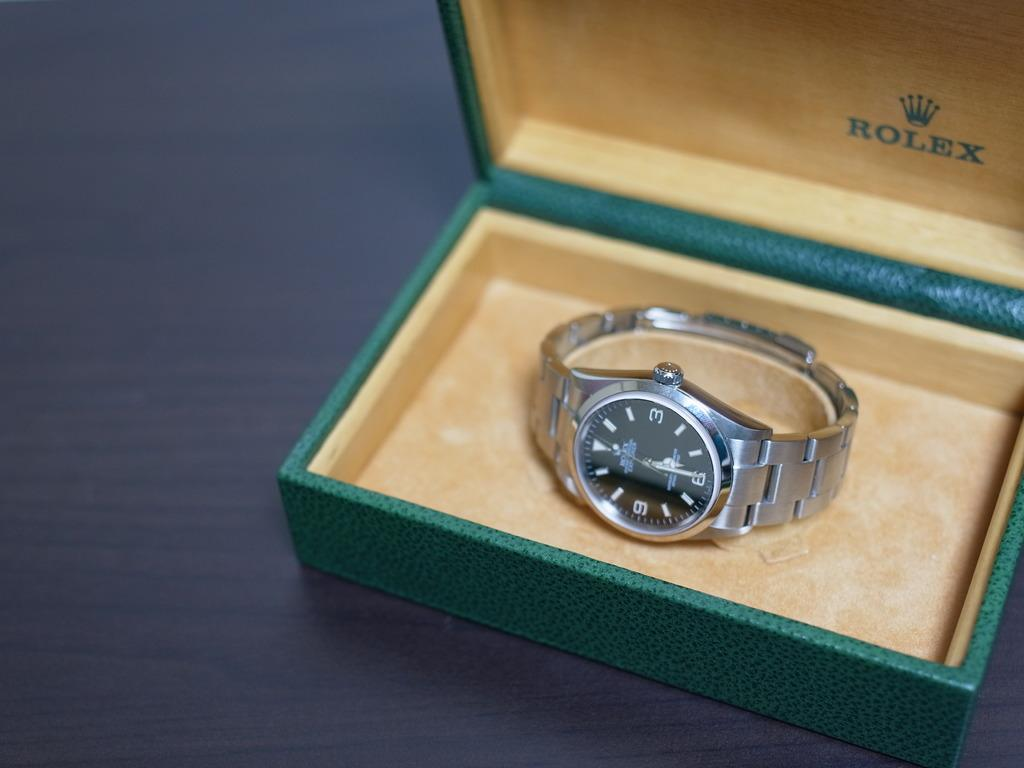<image>
Describe the image concisely. Silver and black watch inside of a Rolex box. 